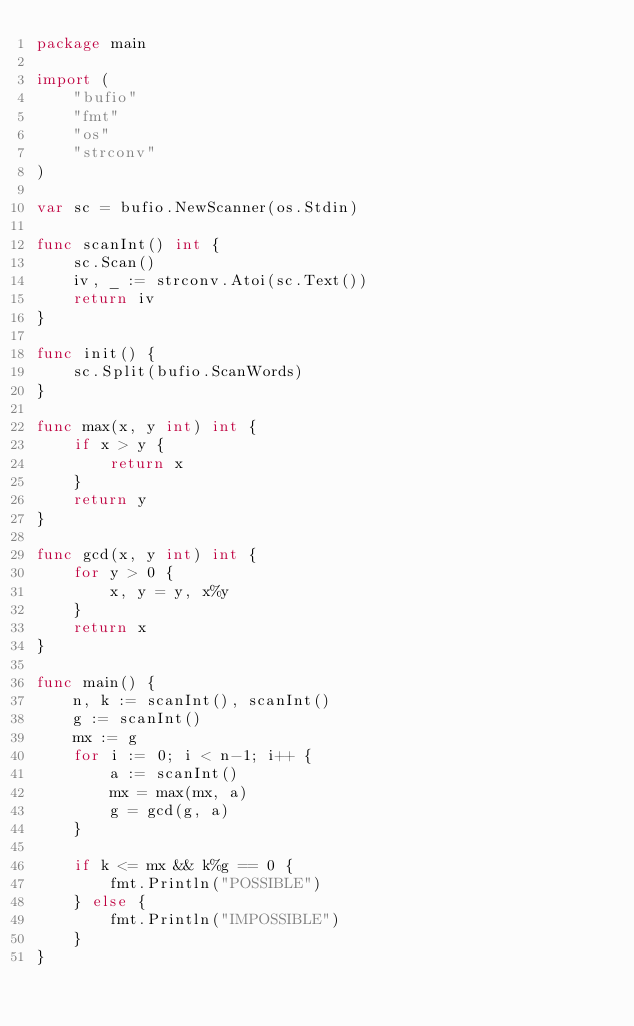Convert code to text. <code><loc_0><loc_0><loc_500><loc_500><_Go_>package main

import (
	"bufio"
	"fmt"
	"os"
	"strconv"
)

var sc = bufio.NewScanner(os.Stdin)

func scanInt() int {
	sc.Scan()
	iv, _ := strconv.Atoi(sc.Text())
	return iv
}

func init() {
	sc.Split(bufio.ScanWords)
}

func max(x, y int) int {
	if x > y {
		return x
	}
	return y
}

func gcd(x, y int) int {
	for y > 0 {
		x, y = y, x%y
	}
	return x
}

func main() {
	n, k := scanInt(), scanInt()
	g := scanInt()
	mx := g
	for i := 0; i < n-1; i++ {
		a := scanInt()
		mx = max(mx, a)
		g = gcd(g, a)
	}

	if k <= mx && k%g == 0 {
		fmt.Println("POSSIBLE")
	} else {
		fmt.Println("IMPOSSIBLE")
	}
}
</code> 